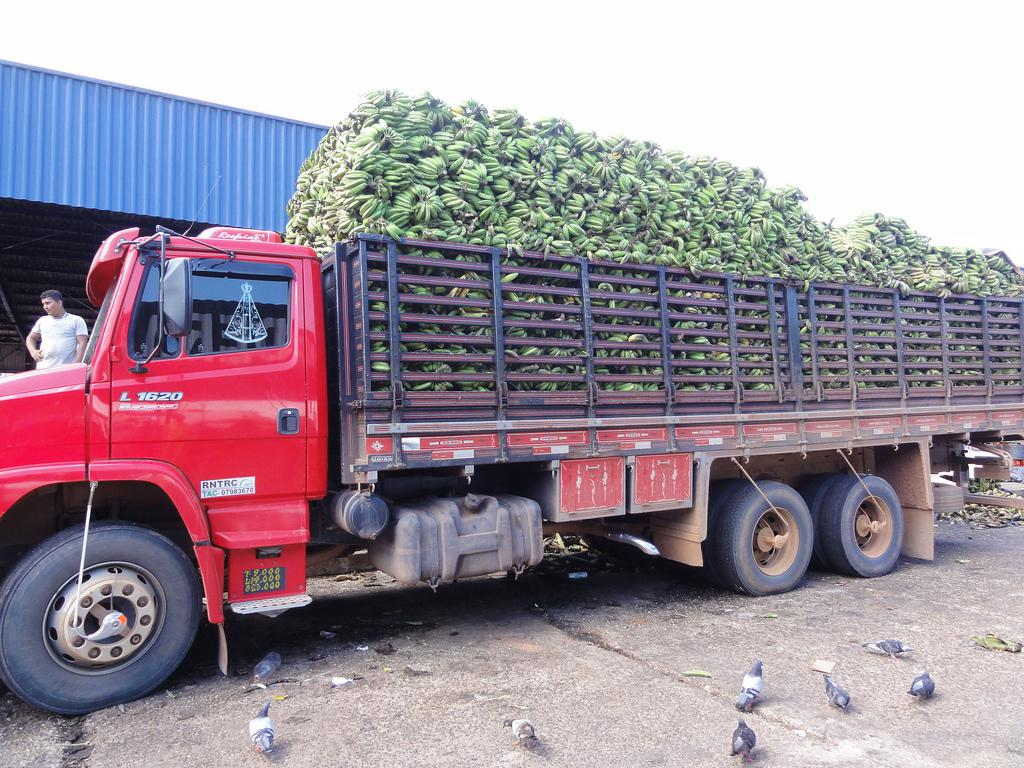Question: who drives the truck?
Choices:
A. Farmer.
B. UPS Driver.
C. Truck driver.
D. Fedex driver.
Answer with the letter. Answer: C Question: what is the on the truck?
Choices:
A. Watermelons.
B. Grapes.
C. Bananas.
D. Cantalopes.
Answer with the letter. Answer: C Question: what color are the bananas?
Choices:
A. Yellow.
B. Brown.
C. Green.
D. Gold.
Answer with the letter. Answer: C Question: what color is the truck?
Choices:
A. Blue.
B. Red.
C. White.
D. Brown.
Answer with the letter. Answer: B Question: where is the truck parked?
Choices:
A. On the side of the road.
B. In the middle of the road.
C. On the dirt.
D. On the pavement.
Answer with the letter. Answer: D Question: why are the pigeons pecking the ground?
Choices:
A. Eating bread.
B. Eating grass.
C. Eating seed.
D. Eating banana.
Answer with the letter. Answer: D Question: why are bananas falling?
Choices:
A. The truck is falling over.
B. The truck is overfilled.
C. The truck is improperly loaded.
D. The truck went over a speed bump too fast.
Answer with the letter. Answer: B Question: what is on the window of the truck?
Choices:
A. A gun rack.
B. A sticker.
C. An advertisement.
D. A design.
Answer with the letter. Answer: D Question: what is the truck overflowing with?
Choices:
A. Beans.
B. Bananas.
C. Watermelons.
D. Cantaloupe.
Answer with the letter. Answer: B Question: where is the truck parked?
Choices:
A. By the sidewalk.
B. In front of a blue building.
C. In the driveway.
D. Outside the market.
Answer with the letter. Answer: B Question: who is wearing a white shirt?
Choices:
A. Woman in the front.
B. Boy in the center.
C. Girl in the mist.
D. The man in the background.
Answer with the letter. Answer: D Question: why is the truck overflowing?
Choices:
A. The stack of pallets.
B. Too much water.
C. The stack of logs.
D. The stack of bananas.
Answer with the letter. Answer: D Question: where are there lots of pigeons?
Choices:
A. On the ground.
B. In the sky.
C. On the phone wire.
D. In the park.
Answer with the letter. Answer: A Question: what is gray?
Choices:
A. The mare.
B. Older people's hair.
C. Naval ships.
D. Truck's tires.
Answer with the letter. Answer: D Question: what has vertical siding?
Choices:
A. Blue building.
B. Barn.
C. Red out building.
D. Portable Garage.
Answer with the letter. Answer: A Question: what is spotted?
Choices:
A. A Dalmatian.
B. A leopard.
C. Ground.
D. A pair of polka dot shorts.
Answer with the letter. Answer: C Question: what kind of scene is it?
Choices:
A. Evening.
B. Daytime.
C. Nighttime.
D. Morning.
Answer with the letter. Answer: B 